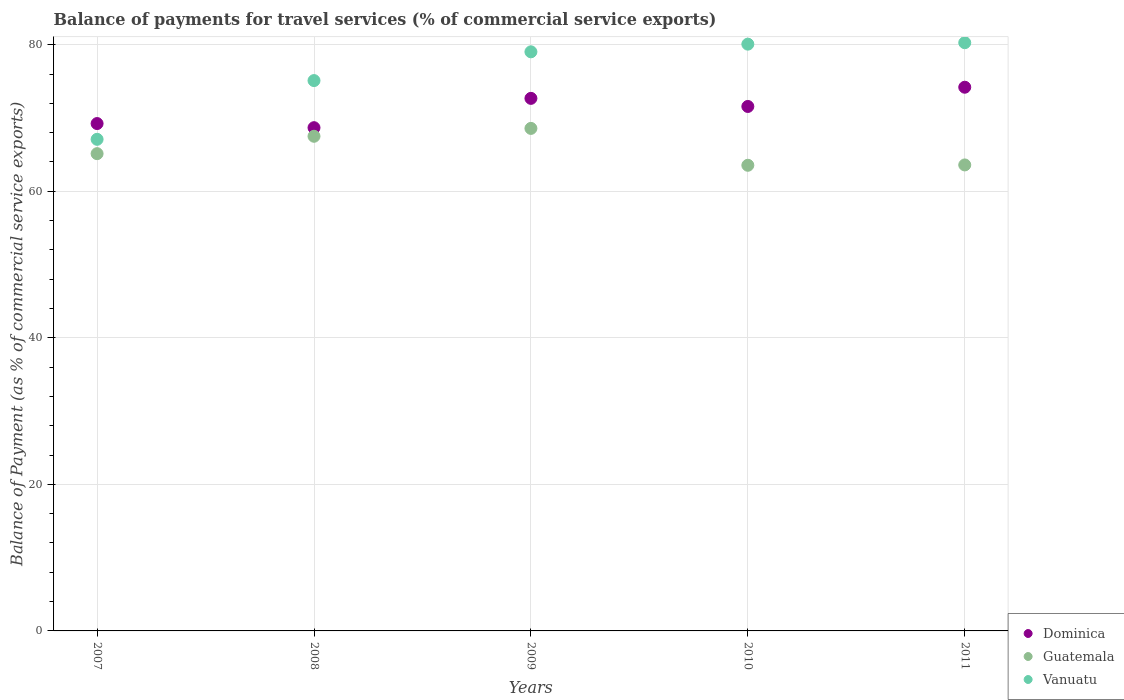Is the number of dotlines equal to the number of legend labels?
Offer a very short reply. Yes. What is the balance of payments for travel services in Guatemala in 2009?
Make the answer very short. 68.58. Across all years, what is the maximum balance of payments for travel services in Guatemala?
Give a very brief answer. 68.58. Across all years, what is the minimum balance of payments for travel services in Vanuatu?
Offer a terse response. 67.09. What is the total balance of payments for travel services in Vanuatu in the graph?
Your answer should be compact. 381.58. What is the difference between the balance of payments for travel services in Dominica in 2007 and that in 2009?
Provide a succinct answer. -3.44. What is the difference between the balance of payments for travel services in Dominica in 2011 and the balance of payments for travel services in Guatemala in 2009?
Give a very brief answer. 5.62. What is the average balance of payments for travel services in Guatemala per year?
Your answer should be very brief. 65.67. In the year 2011, what is the difference between the balance of payments for travel services in Vanuatu and balance of payments for travel services in Guatemala?
Provide a short and direct response. 16.68. What is the ratio of the balance of payments for travel services in Vanuatu in 2009 to that in 2011?
Your answer should be compact. 0.98. Is the balance of payments for travel services in Vanuatu in 2007 less than that in 2008?
Your answer should be compact. Yes. What is the difference between the highest and the second highest balance of payments for travel services in Dominica?
Offer a very short reply. 1.52. What is the difference between the highest and the lowest balance of payments for travel services in Guatemala?
Your answer should be compact. 5.03. Is it the case that in every year, the sum of the balance of payments for travel services in Guatemala and balance of payments for travel services in Dominica  is greater than the balance of payments for travel services in Vanuatu?
Give a very brief answer. Yes. Is the balance of payments for travel services in Guatemala strictly greater than the balance of payments for travel services in Vanuatu over the years?
Make the answer very short. No. How many dotlines are there?
Make the answer very short. 3. How many years are there in the graph?
Ensure brevity in your answer.  5. What is the difference between two consecutive major ticks on the Y-axis?
Provide a succinct answer. 20. Are the values on the major ticks of Y-axis written in scientific E-notation?
Ensure brevity in your answer.  No. Does the graph contain grids?
Offer a terse response. Yes. How many legend labels are there?
Your answer should be very brief. 3. How are the legend labels stacked?
Make the answer very short. Vertical. What is the title of the graph?
Make the answer very short. Balance of payments for travel services (% of commercial service exports). Does "Afghanistan" appear as one of the legend labels in the graph?
Offer a very short reply. No. What is the label or title of the X-axis?
Make the answer very short. Years. What is the label or title of the Y-axis?
Give a very brief answer. Balance of Payment (as % of commercial service exports). What is the Balance of Payment (as % of commercial service exports) of Dominica in 2007?
Your answer should be very brief. 69.24. What is the Balance of Payment (as % of commercial service exports) in Guatemala in 2007?
Offer a very short reply. 65.13. What is the Balance of Payment (as % of commercial service exports) in Vanuatu in 2007?
Provide a short and direct response. 67.09. What is the Balance of Payment (as % of commercial service exports) of Dominica in 2008?
Your answer should be very brief. 68.68. What is the Balance of Payment (as % of commercial service exports) of Guatemala in 2008?
Your answer should be very brief. 67.51. What is the Balance of Payment (as % of commercial service exports) in Vanuatu in 2008?
Offer a very short reply. 75.11. What is the Balance of Payment (as % of commercial service exports) of Dominica in 2009?
Your answer should be very brief. 72.68. What is the Balance of Payment (as % of commercial service exports) in Guatemala in 2009?
Provide a succinct answer. 68.58. What is the Balance of Payment (as % of commercial service exports) of Vanuatu in 2009?
Provide a short and direct response. 79.03. What is the Balance of Payment (as % of commercial service exports) in Dominica in 2010?
Offer a very short reply. 71.57. What is the Balance of Payment (as % of commercial service exports) of Guatemala in 2010?
Provide a succinct answer. 63.55. What is the Balance of Payment (as % of commercial service exports) in Vanuatu in 2010?
Your answer should be very brief. 80.08. What is the Balance of Payment (as % of commercial service exports) in Dominica in 2011?
Make the answer very short. 74.2. What is the Balance of Payment (as % of commercial service exports) in Guatemala in 2011?
Provide a short and direct response. 63.59. What is the Balance of Payment (as % of commercial service exports) of Vanuatu in 2011?
Give a very brief answer. 80.28. Across all years, what is the maximum Balance of Payment (as % of commercial service exports) of Dominica?
Ensure brevity in your answer.  74.2. Across all years, what is the maximum Balance of Payment (as % of commercial service exports) of Guatemala?
Your response must be concise. 68.58. Across all years, what is the maximum Balance of Payment (as % of commercial service exports) in Vanuatu?
Provide a succinct answer. 80.28. Across all years, what is the minimum Balance of Payment (as % of commercial service exports) of Dominica?
Offer a terse response. 68.68. Across all years, what is the minimum Balance of Payment (as % of commercial service exports) in Guatemala?
Provide a short and direct response. 63.55. Across all years, what is the minimum Balance of Payment (as % of commercial service exports) of Vanuatu?
Ensure brevity in your answer.  67.09. What is the total Balance of Payment (as % of commercial service exports) of Dominica in the graph?
Your response must be concise. 356.37. What is the total Balance of Payment (as % of commercial service exports) of Guatemala in the graph?
Make the answer very short. 328.36. What is the total Balance of Payment (as % of commercial service exports) in Vanuatu in the graph?
Offer a terse response. 381.58. What is the difference between the Balance of Payment (as % of commercial service exports) of Dominica in 2007 and that in 2008?
Provide a succinct answer. 0.56. What is the difference between the Balance of Payment (as % of commercial service exports) in Guatemala in 2007 and that in 2008?
Make the answer very short. -2.37. What is the difference between the Balance of Payment (as % of commercial service exports) in Vanuatu in 2007 and that in 2008?
Provide a succinct answer. -8.02. What is the difference between the Balance of Payment (as % of commercial service exports) of Dominica in 2007 and that in 2009?
Your answer should be compact. -3.44. What is the difference between the Balance of Payment (as % of commercial service exports) in Guatemala in 2007 and that in 2009?
Provide a short and direct response. -3.45. What is the difference between the Balance of Payment (as % of commercial service exports) in Vanuatu in 2007 and that in 2009?
Give a very brief answer. -11.94. What is the difference between the Balance of Payment (as % of commercial service exports) in Dominica in 2007 and that in 2010?
Your answer should be very brief. -2.33. What is the difference between the Balance of Payment (as % of commercial service exports) of Guatemala in 2007 and that in 2010?
Offer a very short reply. 1.59. What is the difference between the Balance of Payment (as % of commercial service exports) of Vanuatu in 2007 and that in 2010?
Offer a terse response. -12.99. What is the difference between the Balance of Payment (as % of commercial service exports) of Dominica in 2007 and that in 2011?
Offer a very short reply. -4.96. What is the difference between the Balance of Payment (as % of commercial service exports) of Guatemala in 2007 and that in 2011?
Give a very brief answer. 1.54. What is the difference between the Balance of Payment (as % of commercial service exports) in Vanuatu in 2007 and that in 2011?
Offer a terse response. -13.18. What is the difference between the Balance of Payment (as % of commercial service exports) of Dominica in 2008 and that in 2009?
Your response must be concise. -4. What is the difference between the Balance of Payment (as % of commercial service exports) of Guatemala in 2008 and that in 2009?
Your answer should be compact. -1.07. What is the difference between the Balance of Payment (as % of commercial service exports) in Vanuatu in 2008 and that in 2009?
Provide a succinct answer. -3.92. What is the difference between the Balance of Payment (as % of commercial service exports) of Dominica in 2008 and that in 2010?
Your answer should be compact. -2.9. What is the difference between the Balance of Payment (as % of commercial service exports) of Guatemala in 2008 and that in 2010?
Your answer should be very brief. 3.96. What is the difference between the Balance of Payment (as % of commercial service exports) in Vanuatu in 2008 and that in 2010?
Provide a succinct answer. -4.97. What is the difference between the Balance of Payment (as % of commercial service exports) in Dominica in 2008 and that in 2011?
Your response must be concise. -5.52. What is the difference between the Balance of Payment (as % of commercial service exports) of Guatemala in 2008 and that in 2011?
Offer a very short reply. 3.91. What is the difference between the Balance of Payment (as % of commercial service exports) of Vanuatu in 2008 and that in 2011?
Make the answer very short. -5.17. What is the difference between the Balance of Payment (as % of commercial service exports) of Dominica in 2009 and that in 2010?
Your answer should be compact. 1.1. What is the difference between the Balance of Payment (as % of commercial service exports) of Guatemala in 2009 and that in 2010?
Your answer should be very brief. 5.03. What is the difference between the Balance of Payment (as % of commercial service exports) in Vanuatu in 2009 and that in 2010?
Your answer should be compact. -1.05. What is the difference between the Balance of Payment (as % of commercial service exports) in Dominica in 2009 and that in 2011?
Offer a terse response. -1.52. What is the difference between the Balance of Payment (as % of commercial service exports) of Guatemala in 2009 and that in 2011?
Your response must be concise. 4.99. What is the difference between the Balance of Payment (as % of commercial service exports) in Vanuatu in 2009 and that in 2011?
Give a very brief answer. -1.24. What is the difference between the Balance of Payment (as % of commercial service exports) in Dominica in 2010 and that in 2011?
Provide a succinct answer. -2.62. What is the difference between the Balance of Payment (as % of commercial service exports) of Guatemala in 2010 and that in 2011?
Your answer should be compact. -0.05. What is the difference between the Balance of Payment (as % of commercial service exports) in Vanuatu in 2010 and that in 2011?
Offer a terse response. -0.2. What is the difference between the Balance of Payment (as % of commercial service exports) in Dominica in 2007 and the Balance of Payment (as % of commercial service exports) in Guatemala in 2008?
Ensure brevity in your answer.  1.73. What is the difference between the Balance of Payment (as % of commercial service exports) in Dominica in 2007 and the Balance of Payment (as % of commercial service exports) in Vanuatu in 2008?
Provide a succinct answer. -5.87. What is the difference between the Balance of Payment (as % of commercial service exports) of Guatemala in 2007 and the Balance of Payment (as % of commercial service exports) of Vanuatu in 2008?
Your answer should be very brief. -9.97. What is the difference between the Balance of Payment (as % of commercial service exports) of Dominica in 2007 and the Balance of Payment (as % of commercial service exports) of Guatemala in 2009?
Ensure brevity in your answer.  0.66. What is the difference between the Balance of Payment (as % of commercial service exports) of Dominica in 2007 and the Balance of Payment (as % of commercial service exports) of Vanuatu in 2009?
Your response must be concise. -9.79. What is the difference between the Balance of Payment (as % of commercial service exports) of Guatemala in 2007 and the Balance of Payment (as % of commercial service exports) of Vanuatu in 2009?
Your answer should be very brief. -13.9. What is the difference between the Balance of Payment (as % of commercial service exports) of Dominica in 2007 and the Balance of Payment (as % of commercial service exports) of Guatemala in 2010?
Make the answer very short. 5.69. What is the difference between the Balance of Payment (as % of commercial service exports) of Dominica in 2007 and the Balance of Payment (as % of commercial service exports) of Vanuatu in 2010?
Offer a very short reply. -10.84. What is the difference between the Balance of Payment (as % of commercial service exports) of Guatemala in 2007 and the Balance of Payment (as % of commercial service exports) of Vanuatu in 2010?
Provide a short and direct response. -14.95. What is the difference between the Balance of Payment (as % of commercial service exports) of Dominica in 2007 and the Balance of Payment (as % of commercial service exports) of Guatemala in 2011?
Your response must be concise. 5.65. What is the difference between the Balance of Payment (as % of commercial service exports) in Dominica in 2007 and the Balance of Payment (as % of commercial service exports) in Vanuatu in 2011?
Provide a succinct answer. -11.03. What is the difference between the Balance of Payment (as % of commercial service exports) of Guatemala in 2007 and the Balance of Payment (as % of commercial service exports) of Vanuatu in 2011?
Your answer should be compact. -15.14. What is the difference between the Balance of Payment (as % of commercial service exports) in Dominica in 2008 and the Balance of Payment (as % of commercial service exports) in Guatemala in 2009?
Your response must be concise. 0.1. What is the difference between the Balance of Payment (as % of commercial service exports) in Dominica in 2008 and the Balance of Payment (as % of commercial service exports) in Vanuatu in 2009?
Provide a succinct answer. -10.35. What is the difference between the Balance of Payment (as % of commercial service exports) of Guatemala in 2008 and the Balance of Payment (as % of commercial service exports) of Vanuatu in 2009?
Your answer should be compact. -11.52. What is the difference between the Balance of Payment (as % of commercial service exports) of Dominica in 2008 and the Balance of Payment (as % of commercial service exports) of Guatemala in 2010?
Keep it short and to the point. 5.13. What is the difference between the Balance of Payment (as % of commercial service exports) in Dominica in 2008 and the Balance of Payment (as % of commercial service exports) in Vanuatu in 2010?
Ensure brevity in your answer.  -11.4. What is the difference between the Balance of Payment (as % of commercial service exports) in Guatemala in 2008 and the Balance of Payment (as % of commercial service exports) in Vanuatu in 2010?
Give a very brief answer. -12.57. What is the difference between the Balance of Payment (as % of commercial service exports) of Dominica in 2008 and the Balance of Payment (as % of commercial service exports) of Guatemala in 2011?
Provide a short and direct response. 5.08. What is the difference between the Balance of Payment (as % of commercial service exports) of Dominica in 2008 and the Balance of Payment (as % of commercial service exports) of Vanuatu in 2011?
Provide a short and direct response. -11.6. What is the difference between the Balance of Payment (as % of commercial service exports) of Guatemala in 2008 and the Balance of Payment (as % of commercial service exports) of Vanuatu in 2011?
Provide a short and direct response. -12.77. What is the difference between the Balance of Payment (as % of commercial service exports) in Dominica in 2009 and the Balance of Payment (as % of commercial service exports) in Guatemala in 2010?
Keep it short and to the point. 9.13. What is the difference between the Balance of Payment (as % of commercial service exports) of Dominica in 2009 and the Balance of Payment (as % of commercial service exports) of Vanuatu in 2010?
Offer a terse response. -7.4. What is the difference between the Balance of Payment (as % of commercial service exports) of Guatemala in 2009 and the Balance of Payment (as % of commercial service exports) of Vanuatu in 2010?
Give a very brief answer. -11.5. What is the difference between the Balance of Payment (as % of commercial service exports) of Dominica in 2009 and the Balance of Payment (as % of commercial service exports) of Guatemala in 2011?
Provide a short and direct response. 9.09. What is the difference between the Balance of Payment (as % of commercial service exports) in Dominica in 2009 and the Balance of Payment (as % of commercial service exports) in Vanuatu in 2011?
Your answer should be very brief. -7.6. What is the difference between the Balance of Payment (as % of commercial service exports) in Guatemala in 2009 and the Balance of Payment (as % of commercial service exports) in Vanuatu in 2011?
Offer a terse response. -11.7. What is the difference between the Balance of Payment (as % of commercial service exports) in Dominica in 2010 and the Balance of Payment (as % of commercial service exports) in Guatemala in 2011?
Give a very brief answer. 7.98. What is the difference between the Balance of Payment (as % of commercial service exports) of Dominica in 2010 and the Balance of Payment (as % of commercial service exports) of Vanuatu in 2011?
Provide a short and direct response. -8.7. What is the difference between the Balance of Payment (as % of commercial service exports) of Guatemala in 2010 and the Balance of Payment (as % of commercial service exports) of Vanuatu in 2011?
Give a very brief answer. -16.73. What is the average Balance of Payment (as % of commercial service exports) of Dominica per year?
Provide a succinct answer. 71.27. What is the average Balance of Payment (as % of commercial service exports) of Guatemala per year?
Give a very brief answer. 65.67. What is the average Balance of Payment (as % of commercial service exports) in Vanuatu per year?
Offer a terse response. 76.32. In the year 2007, what is the difference between the Balance of Payment (as % of commercial service exports) in Dominica and Balance of Payment (as % of commercial service exports) in Guatemala?
Your answer should be very brief. 4.11. In the year 2007, what is the difference between the Balance of Payment (as % of commercial service exports) of Dominica and Balance of Payment (as % of commercial service exports) of Vanuatu?
Make the answer very short. 2.15. In the year 2007, what is the difference between the Balance of Payment (as % of commercial service exports) in Guatemala and Balance of Payment (as % of commercial service exports) in Vanuatu?
Your response must be concise. -1.96. In the year 2008, what is the difference between the Balance of Payment (as % of commercial service exports) in Dominica and Balance of Payment (as % of commercial service exports) in Guatemala?
Offer a very short reply. 1.17. In the year 2008, what is the difference between the Balance of Payment (as % of commercial service exports) in Dominica and Balance of Payment (as % of commercial service exports) in Vanuatu?
Your answer should be very brief. -6.43. In the year 2008, what is the difference between the Balance of Payment (as % of commercial service exports) in Guatemala and Balance of Payment (as % of commercial service exports) in Vanuatu?
Provide a succinct answer. -7.6. In the year 2009, what is the difference between the Balance of Payment (as % of commercial service exports) in Dominica and Balance of Payment (as % of commercial service exports) in Guatemala?
Give a very brief answer. 4.1. In the year 2009, what is the difference between the Balance of Payment (as % of commercial service exports) in Dominica and Balance of Payment (as % of commercial service exports) in Vanuatu?
Ensure brevity in your answer.  -6.35. In the year 2009, what is the difference between the Balance of Payment (as % of commercial service exports) in Guatemala and Balance of Payment (as % of commercial service exports) in Vanuatu?
Provide a short and direct response. -10.45. In the year 2010, what is the difference between the Balance of Payment (as % of commercial service exports) in Dominica and Balance of Payment (as % of commercial service exports) in Guatemala?
Offer a terse response. 8.03. In the year 2010, what is the difference between the Balance of Payment (as % of commercial service exports) in Dominica and Balance of Payment (as % of commercial service exports) in Vanuatu?
Offer a terse response. -8.5. In the year 2010, what is the difference between the Balance of Payment (as % of commercial service exports) of Guatemala and Balance of Payment (as % of commercial service exports) of Vanuatu?
Your answer should be very brief. -16.53. In the year 2011, what is the difference between the Balance of Payment (as % of commercial service exports) in Dominica and Balance of Payment (as % of commercial service exports) in Guatemala?
Provide a succinct answer. 10.6. In the year 2011, what is the difference between the Balance of Payment (as % of commercial service exports) of Dominica and Balance of Payment (as % of commercial service exports) of Vanuatu?
Ensure brevity in your answer.  -6.08. In the year 2011, what is the difference between the Balance of Payment (as % of commercial service exports) of Guatemala and Balance of Payment (as % of commercial service exports) of Vanuatu?
Your answer should be very brief. -16.68. What is the ratio of the Balance of Payment (as % of commercial service exports) in Dominica in 2007 to that in 2008?
Your answer should be compact. 1.01. What is the ratio of the Balance of Payment (as % of commercial service exports) in Guatemala in 2007 to that in 2008?
Provide a short and direct response. 0.96. What is the ratio of the Balance of Payment (as % of commercial service exports) in Vanuatu in 2007 to that in 2008?
Make the answer very short. 0.89. What is the ratio of the Balance of Payment (as % of commercial service exports) of Dominica in 2007 to that in 2009?
Offer a very short reply. 0.95. What is the ratio of the Balance of Payment (as % of commercial service exports) of Guatemala in 2007 to that in 2009?
Provide a short and direct response. 0.95. What is the ratio of the Balance of Payment (as % of commercial service exports) in Vanuatu in 2007 to that in 2009?
Offer a terse response. 0.85. What is the ratio of the Balance of Payment (as % of commercial service exports) in Dominica in 2007 to that in 2010?
Your answer should be very brief. 0.97. What is the ratio of the Balance of Payment (as % of commercial service exports) of Vanuatu in 2007 to that in 2010?
Provide a succinct answer. 0.84. What is the ratio of the Balance of Payment (as % of commercial service exports) of Dominica in 2007 to that in 2011?
Make the answer very short. 0.93. What is the ratio of the Balance of Payment (as % of commercial service exports) of Guatemala in 2007 to that in 2011?
Ensure brevity in your answer.  1.02. What is the ratio of the Balance of Payment (as % of commercial service exports) of Vanuatu in 2007 to that in 2011?
Your answer should be compact. 0.84. What is the ratio of the Balance of Payment (as % of commercial service exports) in Dominica in 2008 to that in 2009?
Your answer should be compact. 0.94. What is the ratio of the Balance of Payment (as % of commercial service exports) of Guatemala in 2008 to that in 2009?
Ensure brevity in your answer.  0.98. What is the ratio of the Balance of Payment (as % of commercial service exports) of Vanuatu in 2008 to that in 2009?
Your response must be concise. 0.95. What is the ratio of the Balance of Payment (as % of commercial service exports) of Dominica in 2008 to that in 2010?
Offer a terse response. 0.96. What is the ratio of the Balance of Payment (as % of commercial service exports) of Guatemala in 2008 to that in 2010?
Your response must be concise. 1.06. What is the ratio of the Balance of Payment (as % of commercial service exports) in Vanuatu in 2008 to that in 2010?
Provide a succinct answer. 0.94. What is the ratio of the Balance of Payment (as % of commercial service exports) of Dominica in 2008 to that in 2011?
Your answer should be compact. 0.93. What is the ratio of the Balance of Payment (as % of commercial service exports) of Guatemala in 2008 to that in 2011?
Make the answer very short. 1.06. What is the ratio of the Balance of Payment (as % of commercial service exports) of Vanuatu in 2008 to that in 2011?
Keep it short and to the point. 0.94. What is the ratio of the Balance of Payment (as % of commercial service exports) in Dominica in 2009 to that in 2010?
Make the answer very short. 1.02. What is the ratio of the Balance of Payment (as % of commercial service exports) of Guatemala in 2009 to that in 2010?
Offer a very short reply. 1.08. What is the ratio of the Balance of Payment (as % of commercial service exports) in Vanuatu in 2009 to that in 2010?
Make the answer very short. 0.99. What is the ratio of the Balance of Payment (as % of commercial service exports) in Dominica in 2009 to that in 2011?
Your answer should be compact. 0.98. What is the ratio of the Balance of Payment (as % of commercial service exports) of Guatemala in 2009 to that in 2011?
Offer a terse response. 1.08. What is the ratio of the Balance of Payment (as % of commercial service exports) of Vanuatu in 2009 to that in 2011?
Your answer should be very brief. 0.98. What is the ratio of the Balance of Payment (as % of commercial service exports) in Dominica in 2010 to that in 2011?
Provide a succinct answer. 0.96. What is the ratio of the Balance of Payment (as % of commercial service exports) of Guatemala in 2010 to that in 2011?
Your answer should be compact. 1. What is the ratio of the Balance of Payment (as % of commercial service exports) in Vanuatu in 2010 to that in 2011?
Give a very brief answer. 1. What is the difference between the highest and the second highest Balance of Payment (as % of commercial service exports) in Dominica?
Offer a terse response. 1.52. What is the difference between the highest and the second highest Balance of Payment (as % of commercial service exports) in Guatemala?
Offer a very short reply. 1.07. What is the difference between the highest and the second highest Balance of Payment (as % of commercial service exports) in Vanuatu?
Your answer should be very brief. 0.2. What is the difference between the highest and the lowest Balance of Payment (as % of commercial service exports) in Dominica?
Keep it short and to the point. 5.52. What is the difference between the highest and the lowest Balance of Payment (as % of commercial service exports) in Guatemala?
Ensure brevity in your answer.  5.03. What is the difference between the highest and the lowest Balance of Payment (as % of commercial service exports) in Vanuatu?
Your answer should be very brief. 13.18. 